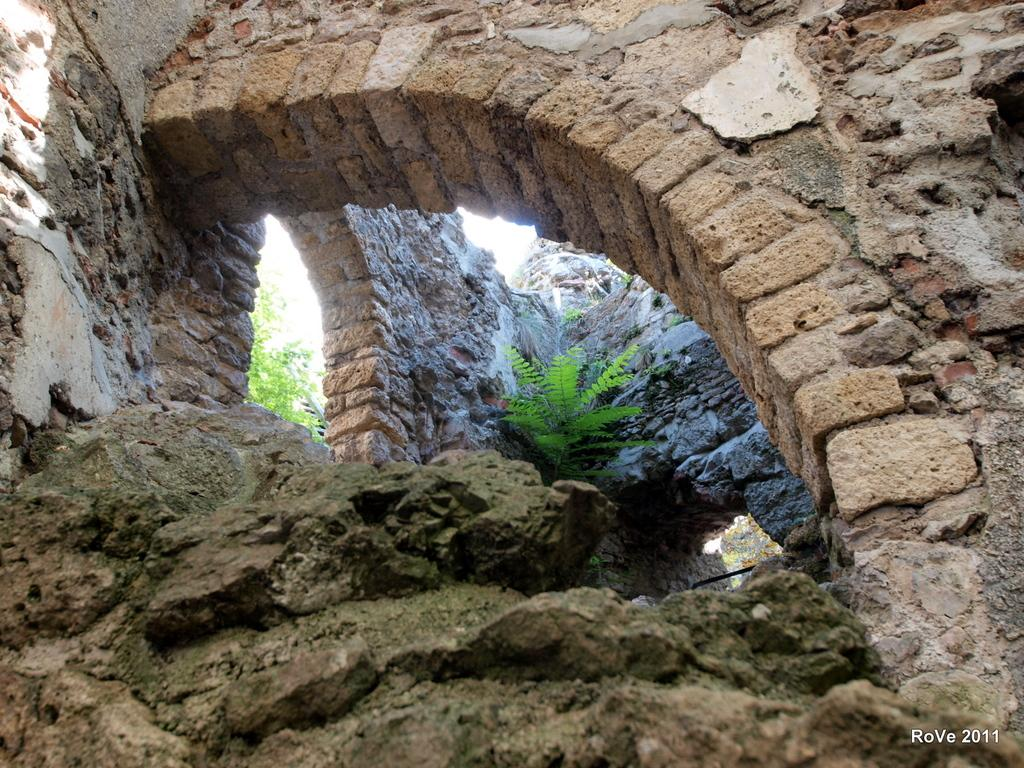What type of structure is visible in the image? There is a stone wall in the image. What else can be seen in the image besides the stone wall? There are plants visible in the image. Is there any text or marking present in the image? Yes, there is a watermark at the bottom right side of the image. How many birds are sitting on the stone wall in the image? There are no birds present in the image. What type of sugar is being used to sweeten the plants in the image? There is no sugar or indication of sweetening the plants in the image. 